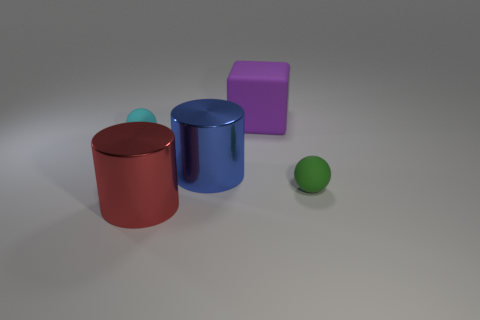What is the material of the object that is both to the left of the large blue object and in front of the tiny cyan sphere? The object in question appears to be a red cylinder, and judging by its visual properties such as the metallic shine and reflections, it is likely made of a type of metal. 